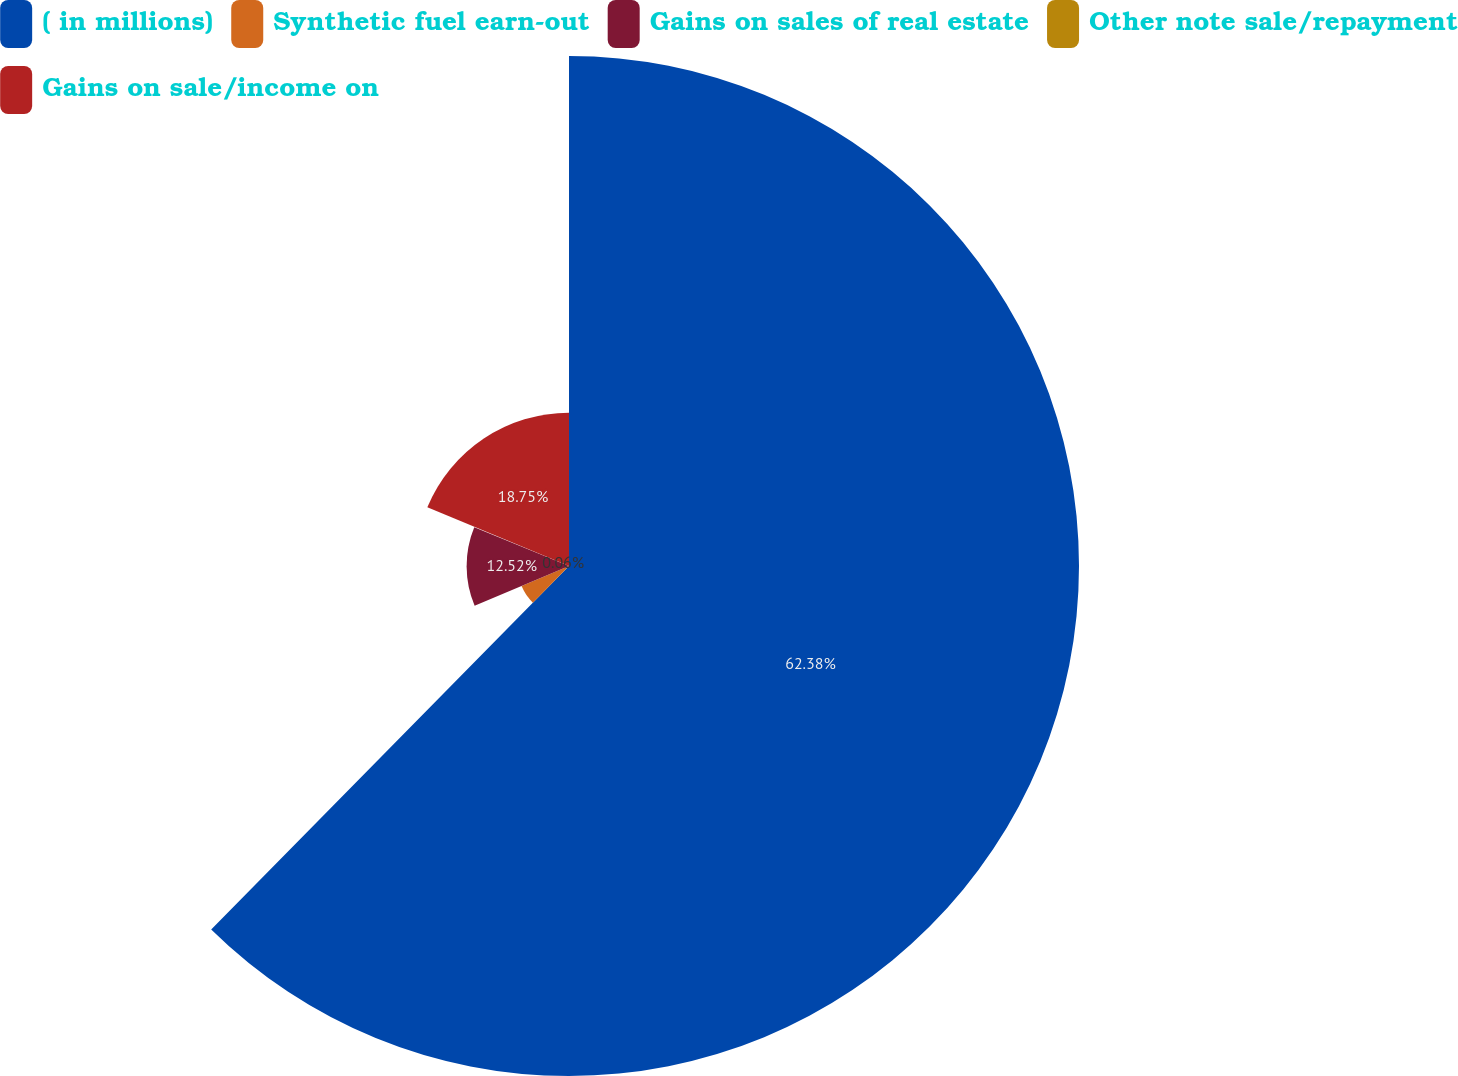Convert chart. <chart><loc_0><loc_0><loc_500><loc_500><pie_chart><fcel>( in millions)<fcel>Synthetic fuel earn-out<fcel>Gains on sales of real estate<fcel>Other note sale/repayment<fcel>Gains on sale/income on<nl><fcel>62.37%<fcel>6.29%<fcel>12.52%<fcel>0.06%<fcel>18.75%<nl></chart> 